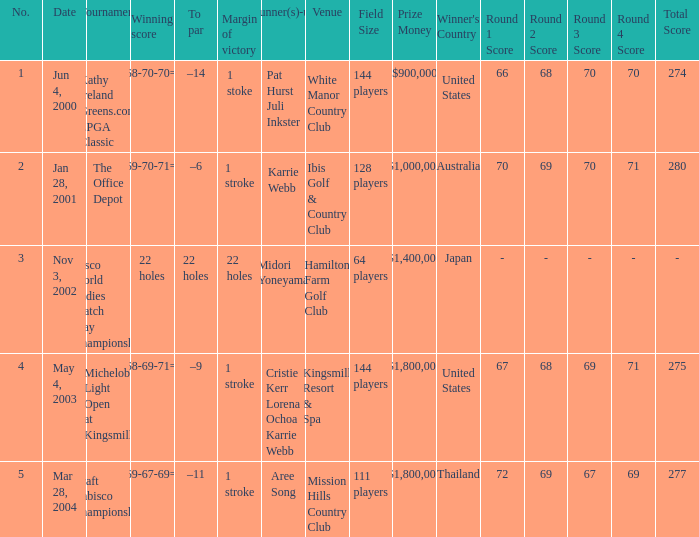What is the to par dated may 4, 2003? –9. 